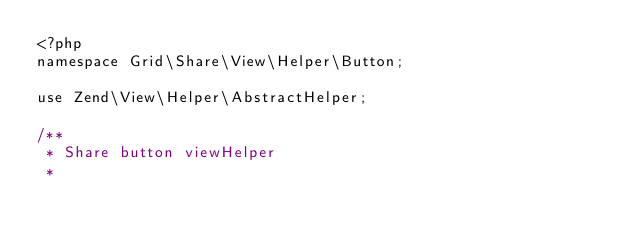Convert code to text. <code><loc_0><loc_0><loc_500><loc_500><_PHP_><?php
namespace Grid\Share\View\Helper\Button;

use Zend\View\Helper\AbstractHelper;

/**
 * Share button viewHelper  
 *</code> 